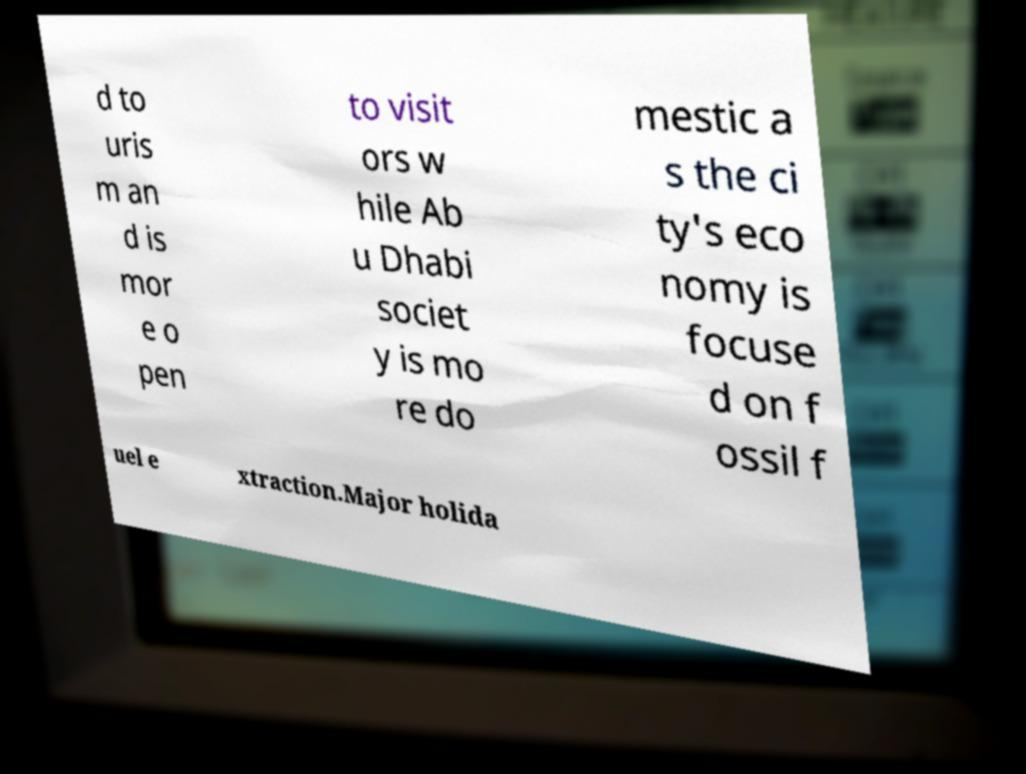Please read and relay the text visible in this image. What does it say? d to uris m an d is mor e o pen to visit ors w hile Ab u Dhabi societ y is mo re do mestic a s the ci ty's eco nomy is focuse d on f ossil f uel e xtraction.Major holida 